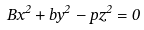Convert formula to latex. <formula><loc_0><loc_0><loc_500><loc_500>B x ^ { 2 } + b y ^ { 2 } - p z ^ { 2 } = 0</formula> 